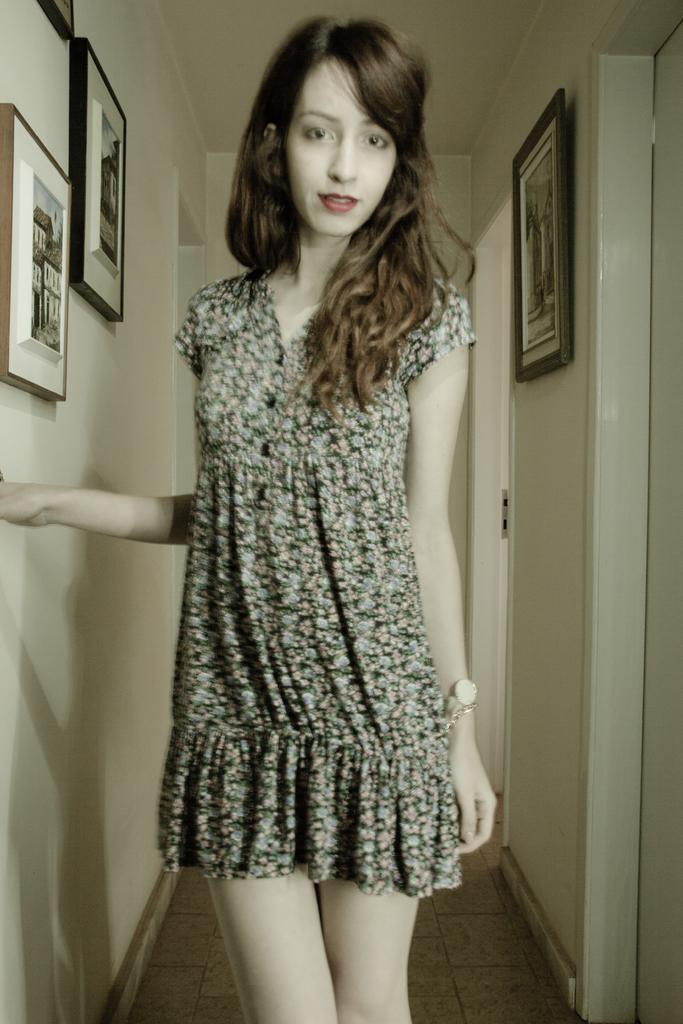Who is present in the image? There is a woman in the image. What is the woman wearing? The woman is wearing a frock. Where is the woman standing in the image? The woman is standing in the middle of a path. What can be seen on either side of the path? There are walls on either side of the path. What is on the walls? The walls have photographs on them. What word is written on the wall in the image? There is no word written on the wall in the image; only photographs are present. 